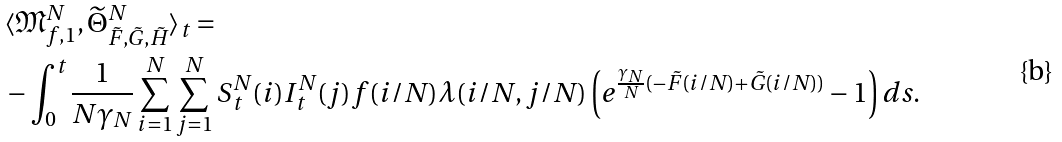Convert formula to latex. <formula><loc_0><loc_0><loc_500><loc_500>& \langle \mathfrak { M } _ { f , 1 } ^ { N } , \widetilde { \Theta } ^ { N } _ { \tilde { F } , \tilde { G } , \tilde { H } } \rangle _ { t } = \\ & - \int _ { 0 } ^ { t } \frac { 1 } { N \gamma _ { N } } \sum _ { i = 1 } ^ { N } \sum _ { j = 1 } ^ { N } S _ { t } ^ { N } ( i ) I _ { t } ^ { N } ( j ) f ( i / N ) \lambda ( i / N , j / N ) \left ( e ^ { \frac { \gamma _ { N } } { N } ( - \tilde { F } ( i / N ) + \tilde { G } ( i / N ) ) } - 1 \right ) d s .</formula> 